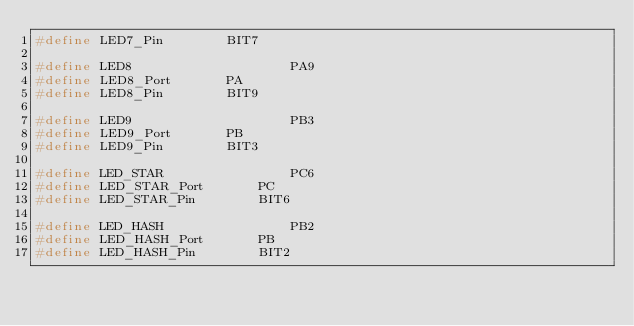<code> <loc_0><loc_0><loc_500><loc_500><_C_>#define LED7_Pin		BIT7

#define LED8                    PA9
#define LED8_Port		PA
#define LED8_Pin		BIT9

#define LED9                    PB3
#define LED9_Port		PB
#define LED9_Pin		BIT3

#define LED_STAR                PC6
#define LED_STAR_Port		PC
#define LED_STAR_Pin		BIT6

#define LED_HASH                PB2
#define LED_HASH_Port		PB
#define LED_HASH_Pin		BIT2

</code> 